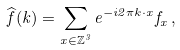<formula> <loc_0><loc_0><loc_500><loc_500>\widehat { f } ( k ) = \sum _ { x \in \mathbb { Z } ^ { 3 } } e ^ { - i 2 \pi k \cdot x } f _ { x } \, ,</formula> 